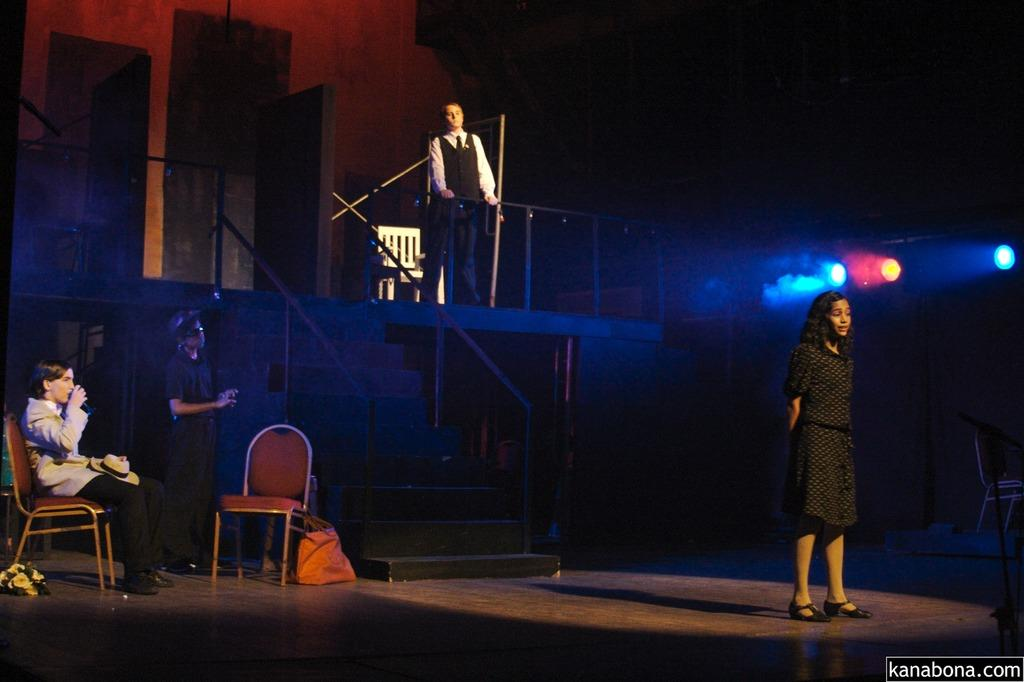How many people are present in the image? There are four people in the image. What are the positions of the people in the image? One person is sitting on a chair, and the other three people are standing. What can be seen on one of the people's heads? There is a hat visible in the image. What type of bag is present in the image? There is a carry bag in the image. What can be seen in the image that provides illumination? There are lights in the image. How many chairs are visible in the image? There are additional chairs in the image. What type of acoustics can be heard in the image? There is no information about any sounds or acoustics in the image, so it cannot be determined. Can you see any boats or ships in the harbor in the image? There is no mention of a harbor or any boats or ships in the image, so it cannot be determined. 